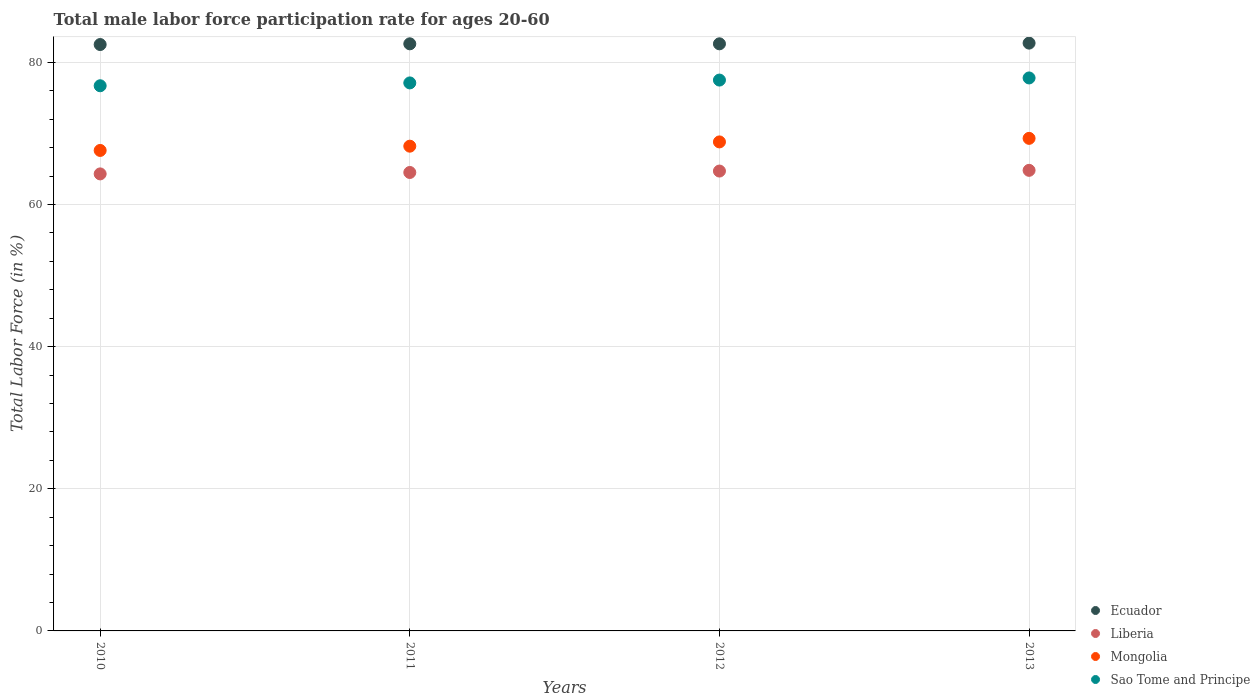How many different coloured dotlines are there?
Offer a terse response. 4. What is the male labor force participation rate in Sao Tome and Principe in 2012?
Ensure brevity in your answer.  77.5. Across all years, what is the maximum male labor force participation rate in Mongolia?
Offer a very short reply. 69.3. Across all years, what is the minimum male labor force participation rate in Mongolia?
Your answer should be compact. 67.6. In which year was the male labor force participation rate in Mongolia minimum?
Offer a terse response. 2010. What is the total male labor force participation rate in Mongolia in the graph?
Make the answer very short. 273.9. What is the difference between the male labor force participation rate in Sao Tome and Principe in 2010 and that in 2012?
Provide a succinct answer. -0.8. What is the difference between the male labor force participation rate in Mongolia in 2010 and the male labor force participation rate in Ecuador in 2012?
Your answer should be very brief. -15. What is the average male labor force participation rate in Ecuador per year?
Your answer should be very brief. 82.6. In the year 2012, what is the difference between the male labor force participation rate in Mongolia and male labor force participation rate in Liberia?
Provide a short and direct response. 4.1. In how many years, is the male labor force participation rate in Liberia greater than 8 %?
Your response must be concise. 4. What is the ratio of the male labor force participation rate in Liberia in 2010 to that in 2011?
Keep it short and to the point. 1. What is the difference between the highest and the second highest male labor force participation rate in Ecuador?
Offer a terse response. 0.1. What is the difference between the highest and the lowest male labor force participation rate in Mongolia?
Offer a terse response. 1.7. In how many years, is the male labor force participation rate in Mongolia greater than the average male labor force participation rate in Mongolia taken over all years?
Give a very brief answer. 2. Is it the case that in every year, the sum of the male labor force participation rate in Mongolia and male labor force participation rate in Ecuador  is greater than the male labor force participation rate in Sao Tome and Principe?
Your answer should be very brief. Yes. Is the male labor force participation rate in Liberia strictly greater than the male labor force participation rate in Ecuador over the years?
Offer a terse response. No. Is the male labor force participation rate in Mongolia strictly less than the male labor force participation rate in Liberia over the years?
Ensure brevity in your answer.  No. What is the difference between two consecutive major ticks on the Y-axis?
Provide a short and direct response. 20. Does the graph contain any zero values?
Provide a succinct answer. No. Does the graph contain grids?
Keep it short and to the point. Yes. How many legend labels are there?
Give a very brief answer. 4. What is the title of the graph?
Your answer should be very brief. Total male labor force participation rate for ages 20-60. Does "Latvia" appear as one of the legend labels in the graph?
Ensure brevity in your answer.  No. What is the Total Labor Force (in %) of Ecuador in 2010?
Make the answer very short. 82.5. What is the Total Labor Force (in %) in Liberia in 2010?
Offer a terse response. 64.3. What is the Total Labor Force (in %) in Mongolia in 2010?
Offer a terse response. 67.6. What is the Total Labor Force (in %) in Sao Tome and Principe in 2010?
Your answer should be very brief. 76.7. What is the Total Labor Force (in %) in Ecuador in 2011?
Keep it short and to the point. 82.6. What is the Total Labor Force (in %) in Liberia in 2011?
Your answer should be very brief. 64.5. What is the Total Labor Force (in %) of Mongolia in 2011?
Your answer should be very brief. 68.2. What is the Total Labor Force (in %) in Sao Tome and Principe in 2011?
Keep it short and to the point. 77.1. What is the Total Labor Force (in %) in Ecuador in 2012?
Offer a very short reply. 82.6. What is the Total Labor Force (in %) in Liberia in 2012?
Keep it short and to the point. 64.7. What is the Total Labor Force (in %) of Mongolia in 2012?
Your response must be concise. 68.8. What is the Total Labor Force (in %) in Sao Tome and Principe in 2012?
Offer a very short reply. 77.5. What is the Total Labor Force (in %) in Ecuador in 2013?
Ensure brevity in your answer.  82.7. What is the Total Labor Force (in %) of Liberia in 2013?
Keep it short and to the point. 64.8. What is the Total Labor Force (in %) in Mongolia in 2013?
Offer a terse response. 69.3. What is the Total Labor Force (in %) of Sao Tome and Principe in 2013?
Your answer should be compact. 77.8. Across all years, what is the maximum Total Labor Force (in %) in Ecuador?
Keep it short and to the point. 82.7. Across all years, what is the maximum Total Labor Force (in %) of Liberia?
Provide a succinct answer. 64.8. Across all years, what is the maximum Total Labor Force (in %) in Mongolia?
Your answer should be compact. 69.3. Across all years, what is the maximum Total Labor Force (in %) of Sao Tome and Principe?
Offer a very short reply. 77.8. Across all years, what is the minimum Total Labor Force (in %) of Ecuador?
Give a very brief answer. 82.5. Across all years, what is the minimum Total Labor Force (in %) in Liberia?
Provide a short and direct response. 64.3. Across all years, what is the minimum Total Labor Force (in %) in Mongolia?
Your answer should be very brief. 67.6. Across all years, what is the minimum Total Labor Force (in %) in Sao Tome and Principe?
Provide a short and direct response. 76.7. What is the total Total Labor Force (in %) of Ecuador in the graph?
Provide a short and direct response. 330.4. What is the total Total Labor Force (in %) of Liberia in the graph?
Offer a very short reply. 258.3. What is the total Total Labor Force (in %) in Mongolia in the graph?
Your answer should be very brief. 273.9. What is the total Total Labor Force (in %) of Sao Tome and Principe in the graph?
Ensure brevity in your answer.  309.1. What is the difference between the Total Labor Force (in %) of Liberia in 2010 and that in 2011?
Provide a short and direct response. -0.2. What is the difference between the Total Labor Force (in %) in Mongolia in 2010 and that in 2011?
Give a very brief answer. -0.6. What is the difference between the Total Labor Force (in %) of Ecuador in 2010 and that in 2012?
Make the answer very short. -0.1. What is the difference between the Total Labor Force (in %) in Liberia in 2010 and that in 2012?
Your response must be concise. -0.4. What is the difference between the Total Labor Force (in %) in Ecuador in 2010 and that in 2013?
Keep it short and to the point. -0.2. What is the difference between the Total Labor Force (in %) of Liberia in 2010 and that in 2013?
Your answer should be compact. -0.5. What is the difference between the Total Labor Force (in %) in Sao Tome and Principe in 2010 and that in 2013?
Ensure brevity in your answer.  -1.1. What is the difference between the Total Labor Force (in %) in Ecuador in 2011 and that in 2012?
Make the answer very short. 0. What is the difference between the Total Labor Force (in %) of Liberia in 2011 and that in 2012?
Give a very brief answer. -0.2. What is the difference between the Total Labor Force (in %) in Sao Tome and Principe in 2012 and that in 2013?
Provide a short and direct response. -0.3. What is the difference between the Total Labor Force (in %) of Ecuador in 2010 and the Total Labor Force (in %) of Mongolia in 2011?
Your answer should be compact. 14.3. What is the difference between the Total Labor Force (in %) in Ecuador in 2010 and the Total Labor Force (in %) in Sao Tome and Principe in 2011?
Ensure brevity in your answer.  5.4. What is the difference between the Total Labor Force (in %) in Mongolia in 2010 and the Total Labor Force (in %) in Sao Tome and Principe in 2011?
Make the answer very short. -9.5. What is the difference between the Total Labor Force (in %) in Ecuador in 2010 and the Total Labor Force (in %) in Liberia in 2012?
Your answer should be very brief. 17.8. What is the difference between the Total Labor Force (in %) in Ecuador in 2010 and the Total Labor Force (in %) in Sao Tome and Principe in 2012?
Provide a short and direct response. 5. What is the difference between the Total Labor Force (in %) of Ecuador in 2010 and the Total Labor Force (in %) of Mongolia in 2013?
Keep it short and to the point. 13.2. What is the difference between the Total Labor Force (in %) of Liberia in 2010 and the Total Labor Force (in %) of Mongolia in 2013?
Your response must be concise. -5. What is the difference between the Total Labor Force (in %) in Mongolia in 2010 and the Total Labor Force (in %) in Sao Tome and Principe in 2013?
Make the answer very short. -10.2. What is the difference between the Total Labor Force (in %) in Ecuador in 2011 and the Total Labor Force (in %) in Liberia in 2012?
Offer a terse response. 17.9. What is the difference between the Total Labor Force (in %) in Ecuador in 2011 and the Total Labor Force (in %) in Mongolia in 2012?
Ensure brevity in your answer.  13.8. What is the difference between the Total Labor Force (in %) of Ecuador in 2011 and the Total Labor Force (in %) of Sao Tome and Principe in 2012?
Keep it short and to the point. 5.1. What is the difference between the Total Labor Force (in %) of Liberia in 2011 and the Total Labor Force (in %) of Sao Tome and Principe in 2013?
Ensure brevity in your answer.  -13.3. What is the difference between the Total Labor Force (in %) in Mongolia in 2011 and the Total Labor Force (in %) in Sao Tome and Principe in 2013?
Provide a short and direct response. -9.6. What is the difference between the Total Labor Force (in %) in Ecuador in 2012 and the Total Labor Force (in %) in Liberia in 2013?
Give a very brief answer. 17.8. What is the difference between the Total Labor Force (in %) in Ecuador in 2012 and the Total Labor Force (in %) in Mongolia in 2013?
Offer a terse response. 13.3. What is the difference between the Total Labor Force (in %) of Liberia in 2012 and the Total Labor Force (in %) of Mongolia in 2013?
Your answer should be compact. -4.6. What is the difference between the Total Labor Force (in %) of Mongolia in 2012 and the Total Labor Force (in %) of Sao Tome and Principe in 2013?
Offer a very short reply. -9. What is the average Total Labor Force (in %) of Ecuador per year?
Keep it short and to the point. 82.6. What is the average Total Labor Force (in %) in Liberia per year?
Keep it short and to the point. 64.58. What is the average Total Labor Force (in %) in Mongolia per year?
Your answer should be compact. 68.47. What is the average Total Labor Force (in %) of Sao Tome and Principe per year?
Make the answer very short. 77.28. In the year 2010, what is the difference between the Total Labor Force (in %) of Liberia and Total Labor Force (in %) of Mongolia?
Offer a terse response. -3.3. In the year 2010, what is the difference between the Total Labor Force (in %) of Liberia and Total Labor Force (in %) of Sao Tome and Principe?
Your answer should be compact. -12.4. In the year 2010, what is the difference between the Total Labor Force (in %) in Mongolia and Total Labor Force (in %) in Sao Tome and Principe?
Offer a terse response. -9.1. In the year 2011, what is the difference between the Total Labor Force (in %) of Ecuador and Total Labor Force (in %) of Mongolia?
Your answer should be compact. 14.4. In the year 2011, what is the difference between the Total Labor Force (in %) in Liberia and Total Labor Force (in %) in Mongolia?
Your response must be concise. -3.7. In the year 2011, what is the difference between the Total Labor Force (in %) in Liberia and Total Labor Force (in %) in Sao Tome and Principe?
Give a very brief answer. -12.6. In the year 2012, what is the difference between the Total Labor Force (in %) in Liberia and Total Labor Force (in %) in Mongolia?
Offer a very short reply. -4.1. In the year 2012, what is the difference between the Total Labor Force (in %) in Mongolia and Total Labor Force (in %) in Sao Tome and Principe?
Give a very brief answer. -8.7. In the year 2013, what is the difference between the Total Labor Force (in %) in Ecuador and Total Labor Force (in %) in Liberia?
Offer a terse response. 17.9. In the year 2013, what is the difference between the Total Labor Force (in %) in Liberia and Total Labor Force (in %) in Mongolia?
Offer a terse response. -4.5. In the year 2013, what is the difference between the Total Labor Force (in %) in Mongolia and Total Labor Force (in %) in Sao Tome and Principe?
Provide a succinct answer. -8.5. What is the ratio of the Total Labor Force (in %) in Liberia in 2010 to that in 2011?
Make the answer very short. 1. What is the ratio of the Total Labor Force (in %) of Sao Tome and Principe in 2010 to that in 2011?
Your answer should be very brief. 0.99. What is the ratio of the Total Labor Force (in %) in Mongolia in 2010 to that in 2012?
Keep it short and to the point. 0.98. What is the ratio of the Total Labor Force (in %) in Sao Tome and Principe in 2010 to that in 2012?
Ensure brevity in your answer.  0.99. What is the ratio of the Total Labor Force (in %) in Ecuador in 2010 to that in 2013?
Ensure brevity in your answer.  1. What is the ratio of the Total Labor Force (in %) of Liberia in 2010 to that in 2013?
Make the answer very short. 0.99. What is the ratio of the Total Labor Force (in %) of Mongolia in 2010 to that in 2013?
Give a very brief answer. 0.98. What is the ratio of the Total Labor Force (in %) in Sao Tome and Principe in 2010 to that in 2013?
Provide a short and direct response. 0.99. What is the ratio of the Total Labor Force (in %) in Ecuador in 2011 to that in 2012?
Ensure brevity in your answer.  1. What is the ratio of the Total Labor Force (in %) in Liberia in 2011 to that in 2012?
Provide a short and direct response. 1. What is the ratio of the Total Labor Force (in %) of Liberia in 2011 to that in 2013?
Provide a succinct answer. 1. What is the ratio of the Total Labor Force (in %) in Mongolia in 2011 to that in 2013?
Provide a short and direct response. 0.98. What is the ratio of the Total Labor Force (in %) in Liberia in 2012 to that in 2013?
Ensure brevity in your answer.  1. What is the ratio of the Total Labor Force (in %) in Mongolia in 2012 to that in 2013?
Offer a very short reply. 0.99. What is the difference between the highest and the second highest Total Labor Force (in %) of Ecuador?
Offer a terse response. 0.1. What is the difference between the highest and the second highest Total Labor Force (in %) of Sao Tome and Principe?
Give a very brief answer. 0.3. What is the difference between the highest and the lowest Total Labor Force (in %) of Ecuador?
Provide a succinct answer. 0.2. What is the difference between the highest and the lowest Total Labor Force (in %) in Sao Tome and Principe?
Offer a very short reply. 1.1. 